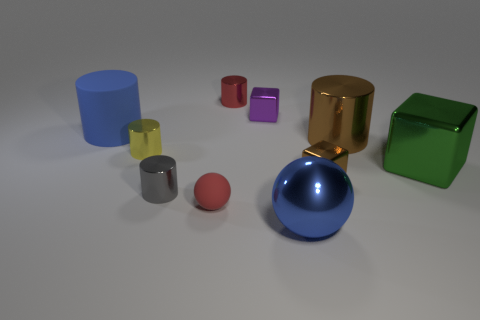The big thing that is to the left of the small red object that is behind the matte object behind the small gray metal thing is what color?
Your answer should be compact. Blue. How many other objects are there of the same size as the green shiny block?
Your answer should be very brief. 3. Is there anything else that has the same shape as the red rubber object?
Provide a short and direct response. Yes. There is a shiny object that is the same shape as the red rubber thing; what is its color?
Your answer should be very brief. Blue. What color is the big cylinder that is the same material as the tiny gray cylinder?
Offer a very short reply. Brown. Are there the same number of purple things that are left of the small rubber object and tiny purple metal spheres?
Offer a terse response. Yes. There is a red thing that is in front of the green metal object; is it the same size as the tiny purple shiny thing?
Your answer should be compact. Yes. What is the color of the ball that is the same size as the green shiny cube?
Make the answer very short. Blue. Is there a shiny cylinder in front of the big cylinder right of the large matte object behind the big cube?
Ensure brevity in your answer.  Yes. There is a big cylinder behind the brown cylinder; what is it made of?
Offer a very short reply. Rubber. 